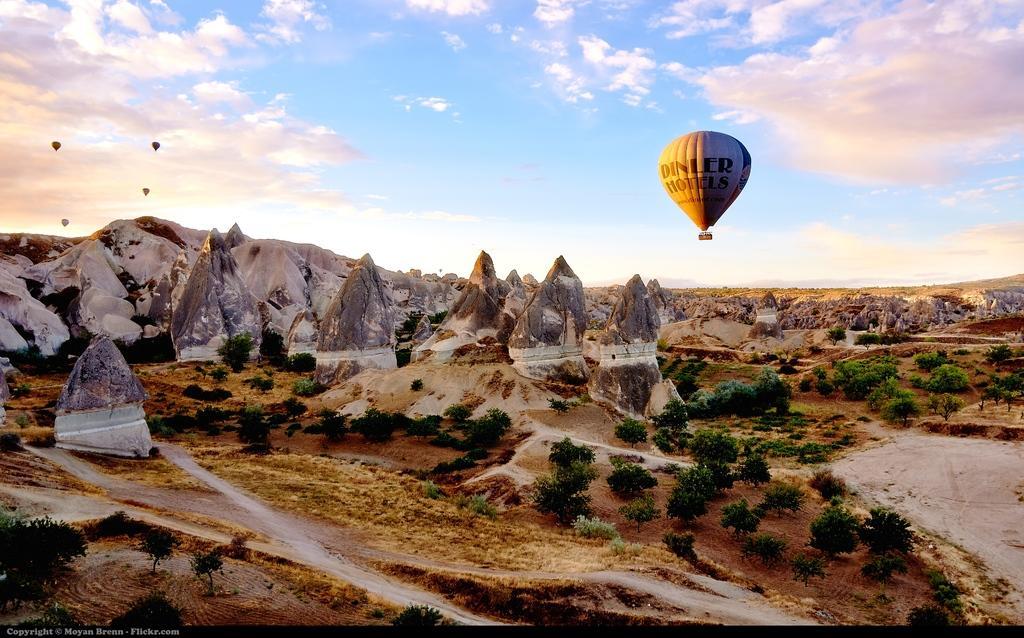In one or two sentences, can you explain what this image depicts? As we can see in the image there are few parachutes, sky, hills and trees here and there. 